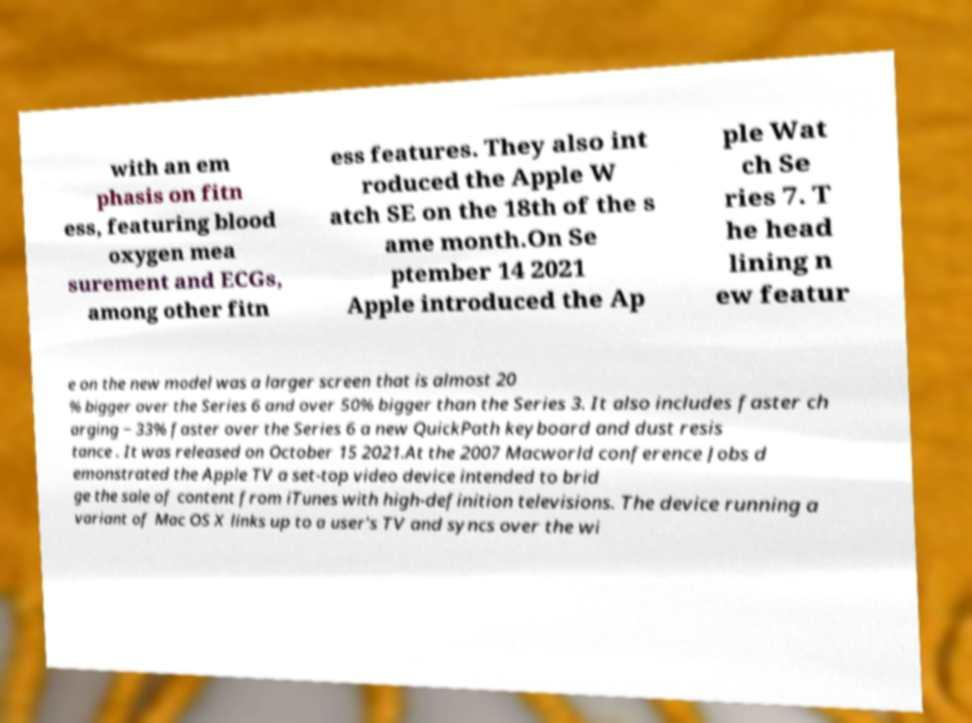Please read and relay the text visible in this image. What does it say? with an em phasis on fitn ess, featuring blood oxygen mea surement and ECGs, among other fitn ess features. They also int roduced the Apple W atch SE on the 18th of the s ame month.On Se ptember 14 2021 Apple introduced the Ap ple Wat ch Se ries 7. T he head lining n ew featur e on the new model was a larger screen that is almost 20 % bigger over the Series 6 and over 50% bigger than the Series 3. It also includes faster ch arging − 33% faster over the Series 6 a new QuickPath keyboard and dust resis tance . It was released on October 15 2021.At the 2007 Macworld conference Jobs d emonstrated the Apple TV a set-top video device intended to brid ge the sale of content from iTunes with high-definition televisions. The device running a variant of Mac OS X links up to a user's TV and syncs over the wi 